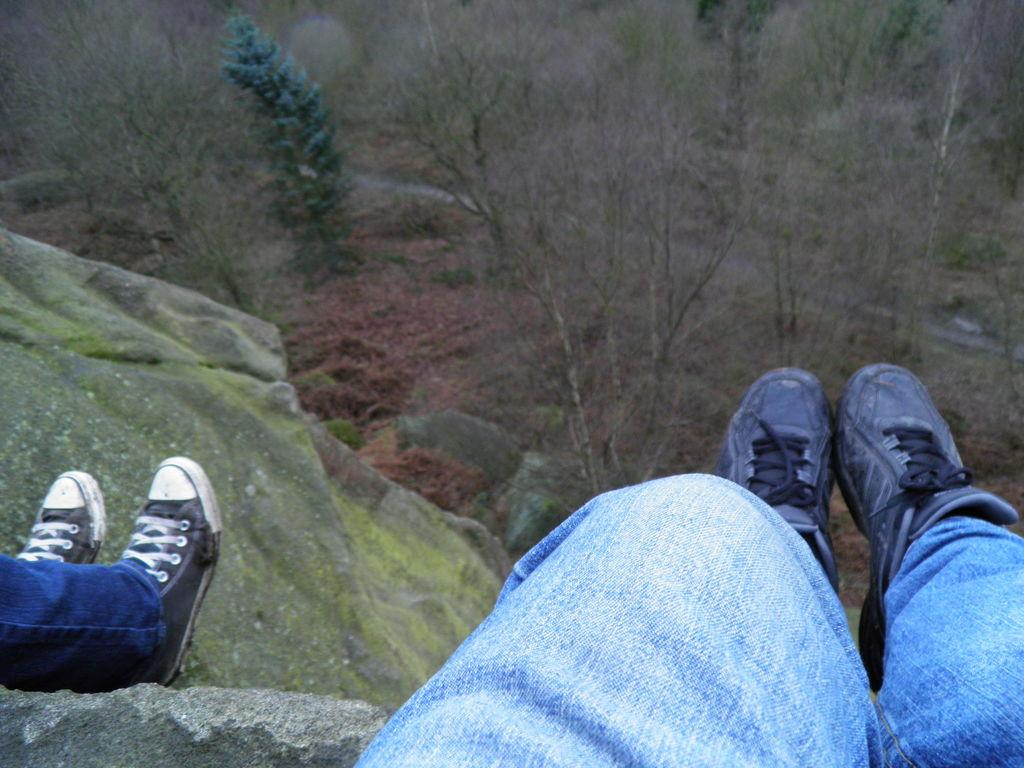What can be seen in the image that indicates the presence of people? There are legs of persons visible in the image. What natural element is present in the image? There is a rock in the image. What type of vegetation can be seen in the image? There are trees in the image. What phase of the moon is visible in the image? There is no moon visible in the image. What type of form does the rock have in the image? The rock does not have a specific form mentioned in the image, so it cannot be determined. 